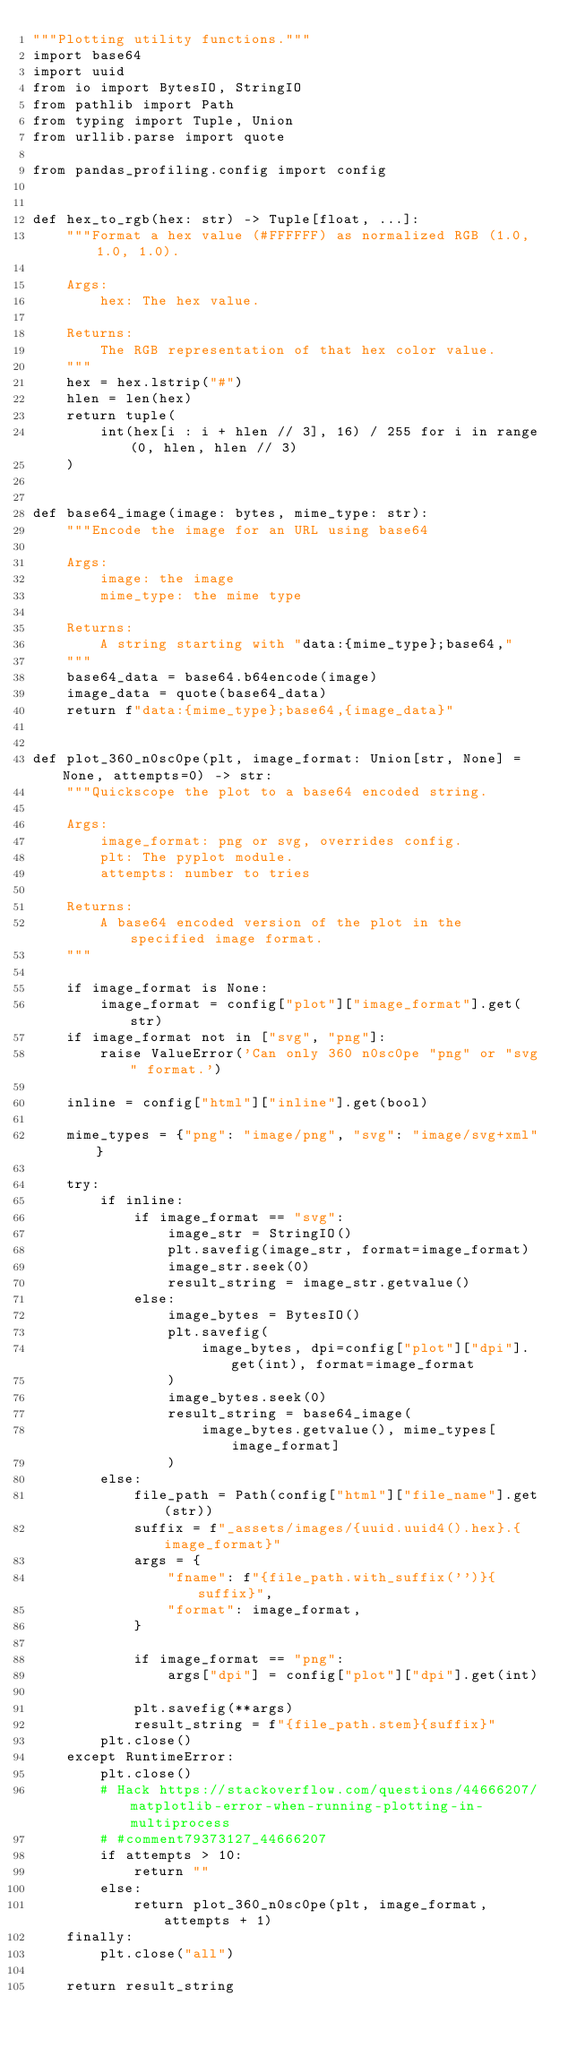<code> <loc_0><loc_0><loc_500><loc_500><_Python_>"""Plotting utility functions."""
import base64
import uuid
from io import BytesIO, StringIO
from pathlib import Path
from typing import Tuple, Union
from urllib.parse import quote

from pandas_profiling.config import config


def hex_to_rgb(hex: str) -> Tuple[float, ...]:
    """Format a hex value (#FFFFFF) as normalized RGB (1.0, 1.0, 1.0).

    Args:
        hex: The hex value.

    Returns:
        The RGB representation of that hex color value.
    """
    hex = hex.lstrip("#")
    hlen = len(hex)
    return tuple(
        int(hex[i : i + hlen // 3], 16) / 255 for i in range(0, hlen, hlen // 3)
    )


def base64_image(image: bytes, mime_type: str):
    """Encode the image for an URL using base64

    Args:
        image: the image
        mime_type: the mime type

    Returns:
        A string starting with "data:{mime_type};base64,"
    """
    base64_data = base64.b64encode(image)
    image_data = quote(base64_data)
    return f"data:{mime_type};base64,{image_data}"


def plot_360_n0sc0pe(plt, image_format: Union[str, None] = None, attempts=0) -> str:
    """Quickscope the plot to a base64 encoded string.

    Args:
        image_format: png or svg, overrides config.
        plt: The pyplot module.
        attempts: number to tries

    Returns:
        A base64 encoded version of the plot in the specified image format.
    """

    if image_format is None:
        image_format = config["plot"]["image_format"].get(str)
    if image_format not in ["svg", "png"]:
        raise ValueError('Can only 360 n0sc0pe "png" or "svg" format.')

    inline = config["html"]["inline"].get(bool)

    mime_types = {"png": "image/png", "svg": "image/svg+xml"}

    try:
        if inline:
            if image_format == "svg":
                image_str = StringIO()
                plt.savefig(image_str, format=image_format)
                image_str.seek(0)
                result_string = image_str.getvalue()
            else:
                image_bytes = BytesIO()
                plt.savefig(
                    image_bytes, dpi=config["plot"]["dpi"].get(int), format=image_format
                )
                image_bytes.seek(0)
                result_string = base64_image(
                    image_bytes.getvalue(), mime_types[image_format]
                )
        else:
            file_path = Path(config["html"]["file_name"].get(str))
            suffix = f"_assets/images/{uuid.uuid4().hex}.{image_format}"
            args = {
                "fname": f"{file_path.with_suffix('')}{suffix}",
                "format": image_format,
            }

            if image_format == "png":
                args["dpi"] = config["plot"]["dpi"].get(int)

            plt.savefig(**args)
            result_string = f"{file_path.stem}{suffix}"
        plt.close()
    except RuntimeError:
        plt.close()
        # Hack https://stackoverflow.com/questions/44666207/matplotlib-error-when-running-plotting-in-multiprocess
        # #comment79373127_44666207
        if attempts > 10:
            return ""
        else:
            return plot_360_n0sc0pe(plt, image_format, attempts + 1)
    finally:
        plt.close("all")

    return result_string
</code> 